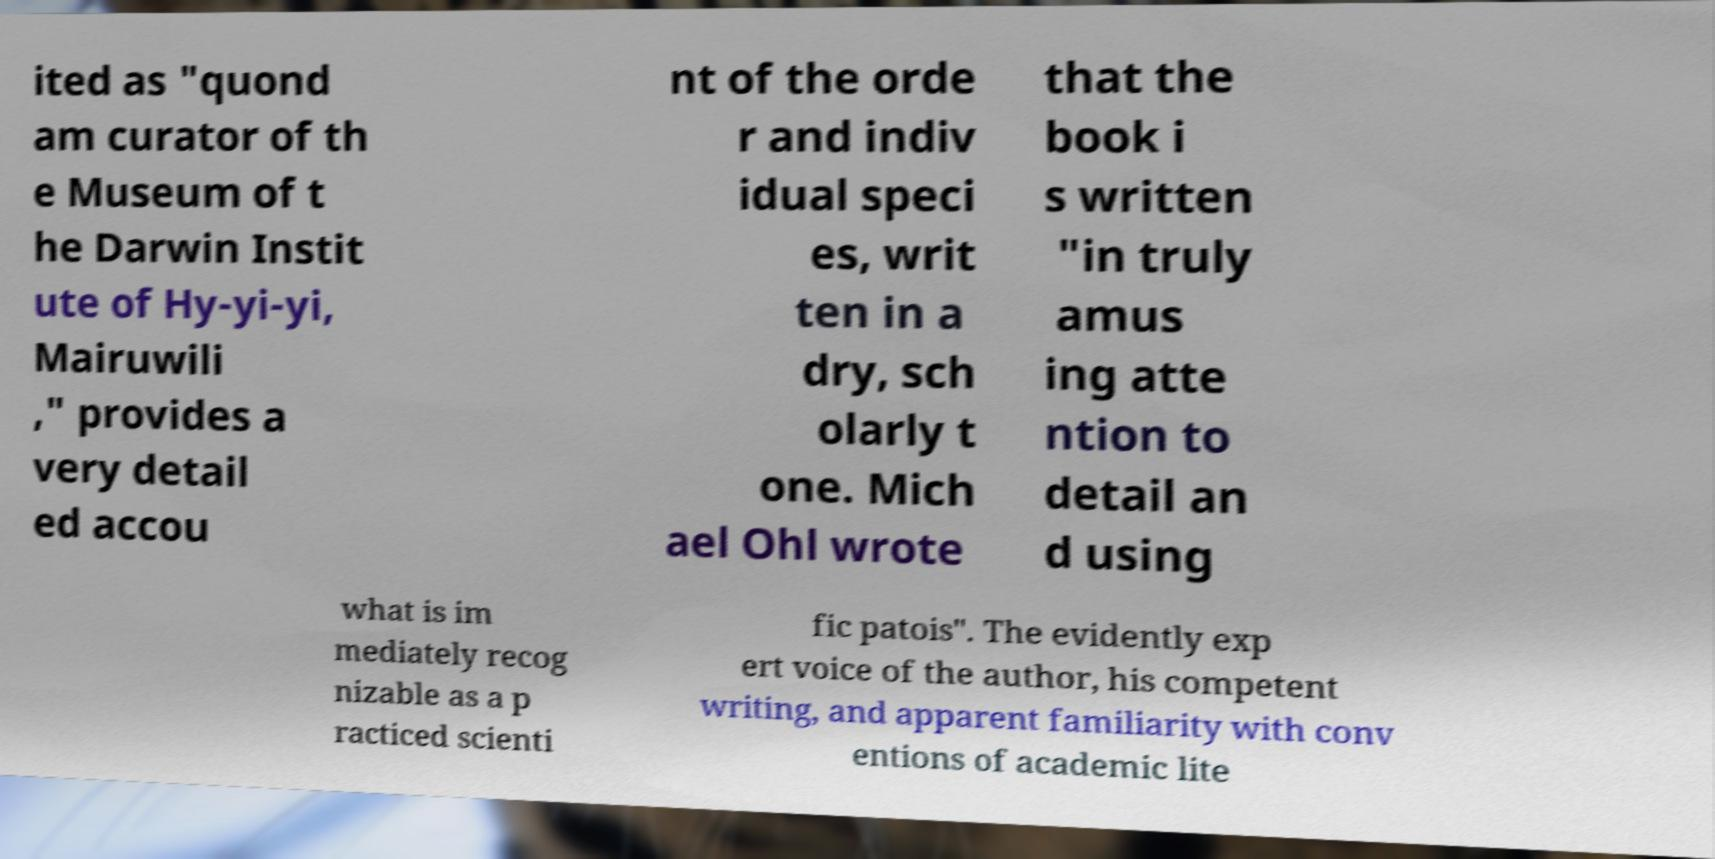Could you assist in decoding the text presented in this image and type it out clearly? ited as "quond am curator of th e Museum of t he Darwin Instit ute of Hy-yi-yi, Mairuwili ," provides a very detail ed accou nt of the orde r and indiv idual speci es, writ ten in a dry, sch olarly t one. Mich ael Ohl wrote that the book i s written "in truly amus ing atte ntion to detail an d using what is im mediately recog nizable as a p racticed scienti fic patois". The evidently exp ert voice of the author, his competent writing, and apparent familiarity with conv entions of academic lite 